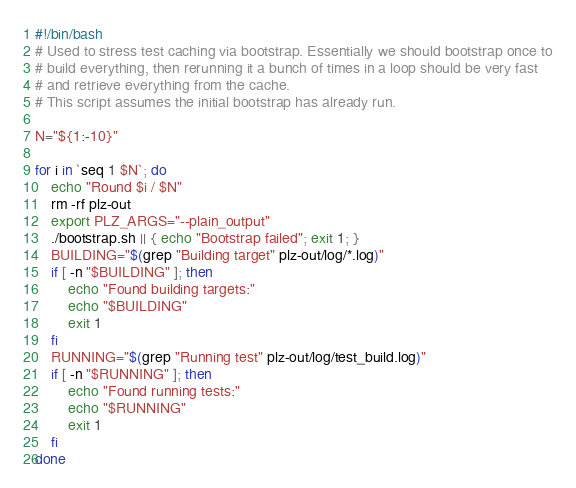Convert code to text. <code><loc_0><loc_0><loc_500><loc_500><_Bash_>#!/bin/bash
# Used to stress test caching via bootstrap. Essentially we should bootstrap once to
# build everything, then rerunning it a bunch of times in a loop should be very fast
# and retrieve everything from the cache.
# This script assumes the initial bootstrap has already run.

N="${1:-10}"

for i in `seq 1 $N`; do
    echo "Round $i / $N"
    rm -rf plz-out
    export PLZ_ARGS="--plain_output"
    ./bootstrap.sh || { echo "Bootstrap failed"; exit 1; }
    BUILDING="$(grep "Building target" plz-out/log/*.log)"
    if [ -n "$BUILDING" ]; then
        echo "Found building targets:"
        echo "$BUILDING"
        exit 1
    fi
    RUNNING="$(grep "Running test" plz-out/log/test_build.log)"
    if [ -n "$RUNNING" ]; then
        echo "Found running tests:"
        echo "$RUNNING"
        exit 1
    fi
done
</code> 